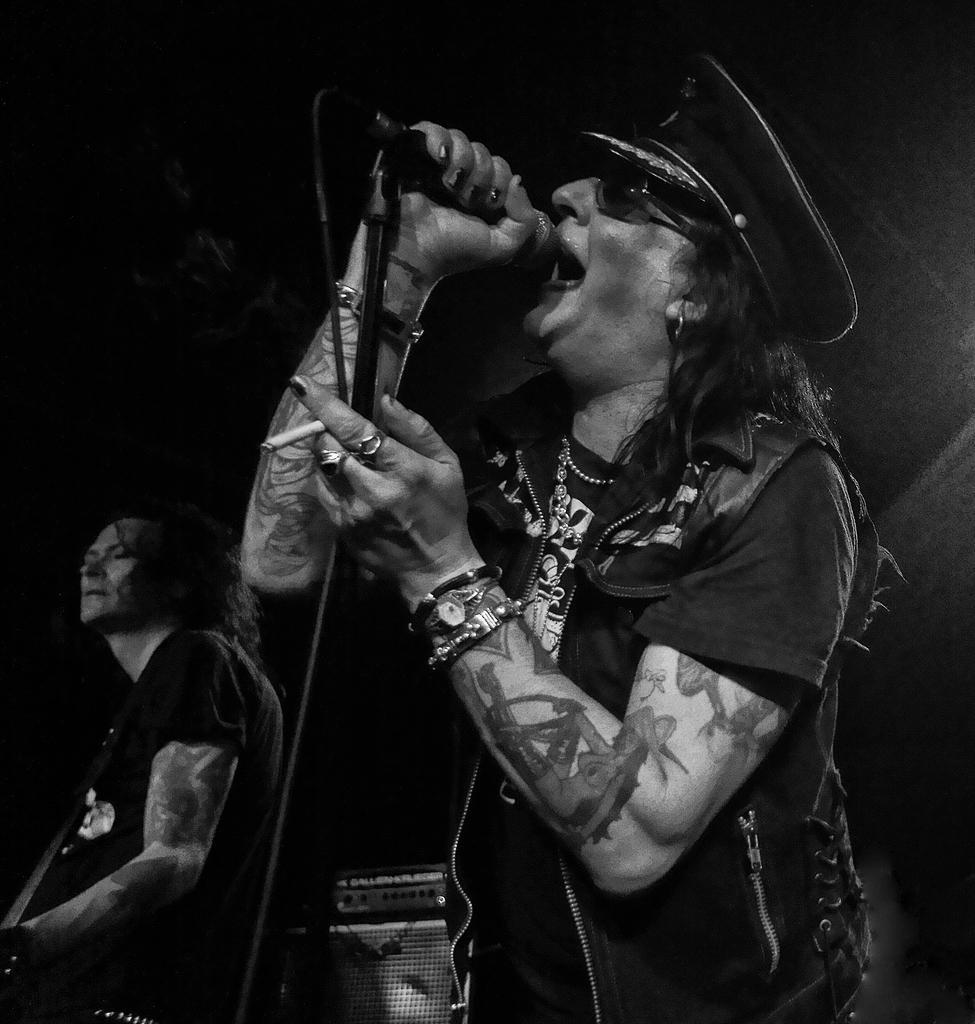Please provide a concise description of this image. In this image I see 2 men in which this man is holding a musical instrument and this man is holding a mic and he is also wearing a cap on his head. In the background I see an equipment. 